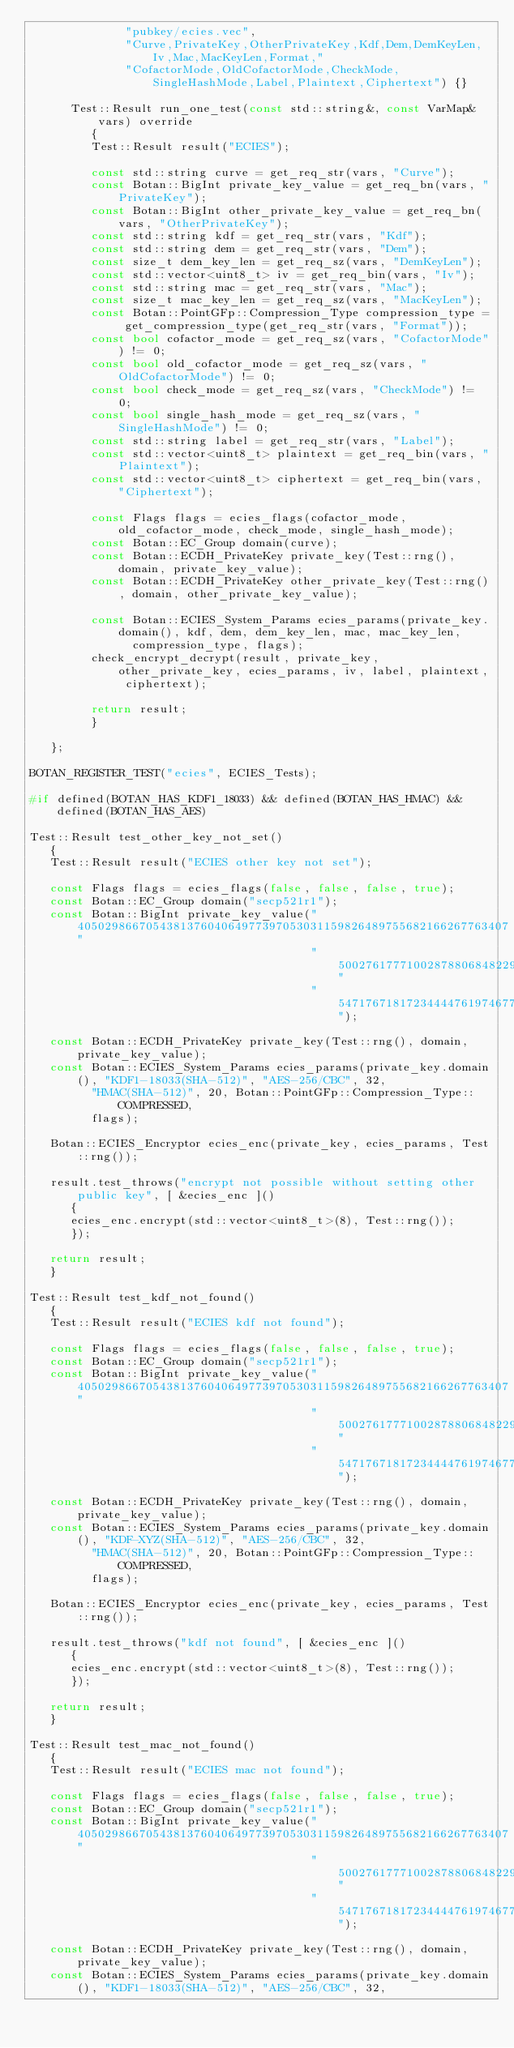<code> <loc_0><loc_0><loc_500><loc_500><_C++_>              "pubkey/ecies.vec",
              "Curve,PrivateKey,OtherPrivateKey,Kdf,Dem,DemKeyLen,Iv,Mac,MacKeyLen,Format,"
              "CofactorMode,OldCofactorMode,CheckMode,SingleHashMode,Label,Plaintext,Ciphertext") {}

      Test::Result run_one_test(const std::string&, const VarMap& vars) override
         {
         Test::Result result("ECIES");

         const std::string curve = get_req_str(vars, "Curve");
         const Botan::BigInt private_key_value = get_req_bn(vars, "PrivateKey");
         const Botan::BigInt other_private_key_value = get_req_bn(vars, "OtherPrivateKey");
         const std::string kdf = get_req_str(vars, "Kdf");
         const std::string dem = get_req_str(vars, "Dem");
         const size_t dem_key_len = get_req_sz(vars, "DemKeyLen");
         const std::vector<uint8_t> iv = get_req_bin(vars, "Iv");
         const std::string mac = get_req_str(vars, "Mac");
         const size_t mac_key_len = get_req_sz(vars, "MacKeyLen");
         const Botan::PointGFp::Compression_Type compression_type = get_compression_type(get_req_str(vars, "Format"));
         const bool cofactor_mode = get_req_sz(vars, "CofactorMode") != 0;
         const bool old_cofactor_mode = get_req_sz(vars, "OldCofactorMode") != 0;
         const bool check_mode = get_req_sz(vars, "CheckMode") != 0;
         const bool single_hash_mode = get_req_sz(vars, "SingleHashMode") != 0;
         const std::string label = get_req_str(vars, "Label");
         const std::vector<uint8_t> plaintext = get_req_bin(vars, "Plaintext");
         const std::vector<uint8_t> ciphertext = get_req_bin(vars, "Ciphertext");

         const Flags flags = ecies_flags(cofactor_mode, old_cofactor_mode, check_mode, single_hash_mode);
         const Botan::EC_Group domain(curve);
         const Botan::ECDH_PrivateKey private_key(Test::rng(), domain, private_key_value);
         const Botan::ECDH_PrivateKey other_private_key(Test::rng(), domain, other_private_key_value);

         const Botan::ECIES_System_Params ecies_params(private_key.domain(), kdf, dem, dem_key_len, mac, mac_key_len,
               compression_type, flags);
         check_encrypt_decrypt(result, private_key, other_private_key, ecies_params, iv, label, plaintext, ciphertext);

         return result;
         }

   };

BOTAN_REGISTER_TEST("ecies", ECIES_Tests);

#if defined(BOTAN_HAS_KDF1_18033) && defined(BOTAN_HAS_HMAC) && defined(BOTAN_HAS_AES)

Test::Result test_other_key_not_set()
   {
   Test::Result result("ECIES other key not set");

   const Flags flags = ecies_flags(false, false, false, true);
   const Botan::EC_Group domain("secp521r1");
   const Botan::BigInt private_key_value("405029866705438137604064977397053031159826489755682166267763407"
                                         "5002761777100287880684822948852132235484464537021197213998300006"
                                         "547176718172344447619746779823");

   const Botan::ECDH_PrivateKey private_key(Test::rng(), domain, private_key_value);
   const Botan::ECIES_System_Params ecies_params(private_key.domain(), "KDF1-18033(SHA-512)", "AES-256/CBC", 32,
         "HMAC(SHA-512)", 20, Botan::PointGFp::Compression_Type::COMPRESSED,
         flags);

   Botan::ECIES_Encryptor ecies_enc(private_key, ecies_params, Test::rng());

   result.test_throws("encrypt not possible without setting other public key", [ &ecies_enc ]()
      {
      ecies_enc.encrypt(std::vector<uint8_t>(8), Test::rng());
      });

   return result;
   }

Test::Result test_kdf_not_found()
   {
   Test::Result result("ECIES kdf not found");

   const Flags flags = ecies_flags(false, false, false, true);
   const Botan::EC_Group domain("secp521r1");
   const Botan::BigInt private_key_value("405029866705438137604064977397053031159826489755682166267763407"
                                         "5002761777100287880684822948852132235484464537021197213998300006"
                                         "547176718172344447619746779823");

   const Botan::ECDH_PrivateKey private_key(Test::rng(), domain, private_key_value);
   const Botan::ECIES_System_Params ecies_params(private_key.domain(), "KDF-XYZ(SHA-512)", "AES-256/CBC", 32,
         "HMAC(SHA-512)", 20, Botan::PointGFp::Compression_Type::COMPRESSED,
         flags);

   Botan::ECIES_Encryptor ecies_enc(private_key, ecies_params, Test::rng());

   result.test_throws("kdf not found", [ &ecies_enc ]()
      {
      ecies_enc.encrypt(std::vector<uint8_t>(8), Test::rng());
      });

   return result;
   }

Test::Result test_mac_not_found()
   {
   Test::Result result("ECIES mac not found");

   const Flags flags = ecies_flags(false, false, false, true);
   const Botan::EC_Group domain("secp521r1");
   const Botan::BigInt private_key_value("405029866705438137604064977397053031159826489755682166267763407"
                                         "5002761777100287880684822948852132235484464537021197213998300006"
                                         "547176718172344447619746779823");

   const Botan::ECDH_PrivateKey private_key(Test::rng(), domain, private_key_value);
   const Botan::ECIES_System_Params ecies_params(private_key.domain(), "KDF1-18033(SHA-512)", "AES-256/CBC", 32,</code> 